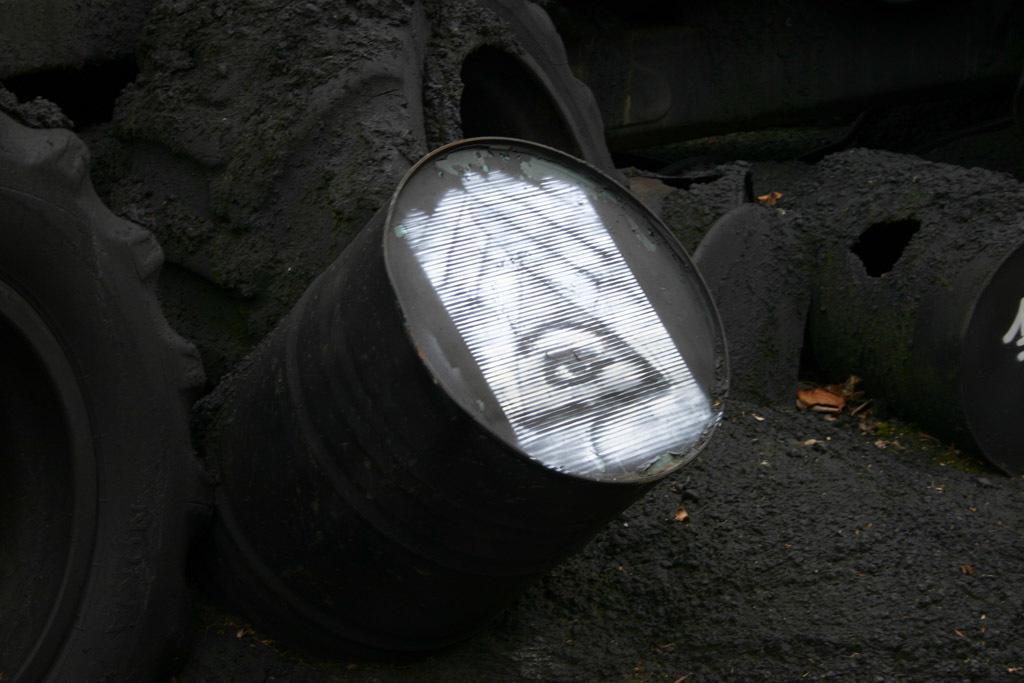Can you describe this image briefly? In this image there are drums and tyres. 